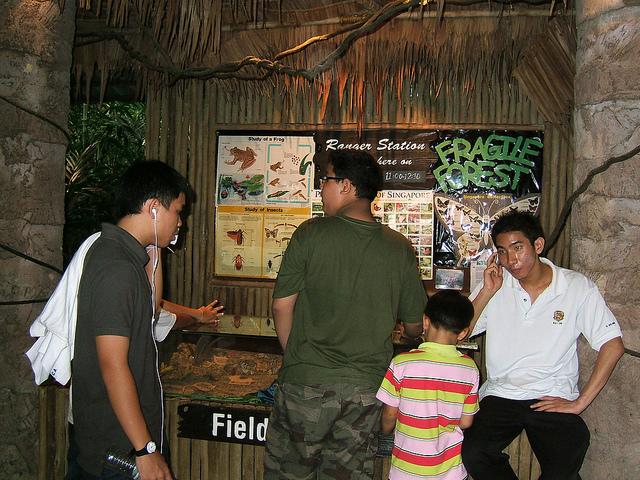Is this a museum?
Short answer required. Yes. Where is a picture of a frog?
Short answer required. Upper left on board. What color is the child's shirt?
Be succinct. Pink. What is in the ear of the boy on the left?
Short answer required. Earbud. How many persons are wearing hats?
Quick response, please. 0. 